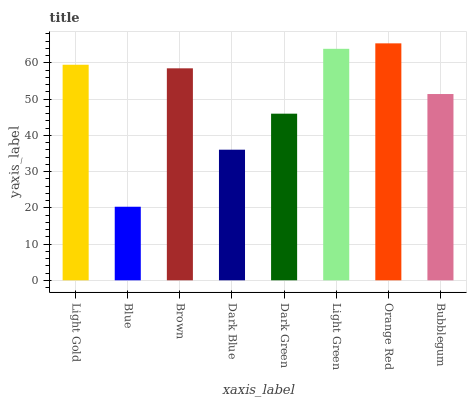Is Blue the minimum?
Answer yes or no. Yes. Is Orange Red the maximum?
Answer yes or no. Yes. Is Brown the minimum?
Answer yes or no. No. Is Brown the maximum?
Answer yes or no. No. Is Brown greater than Blue?
Answer yes or no. Yes. Is Blue less than Brown?
Answer yes or no. Yes. Is Blue greater than Brown?
Answer yes or no. No. Is Brown less than Blue?
Answer yes or no. No. Is Brown the high median?
Answer yes or no. Yes. Is Bubblegum the low median?
Answer yes or no. Yes. Is Blue the high median?
Answer yes or no. No. Is Brown the low median?
Answer yes or no. No. 